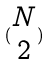Convert formula to latex. <formula><loc_0><loc_0><loc_500><loc_500>( \begin{matrix} N \\ 2 \end{matrix} )</formula> 